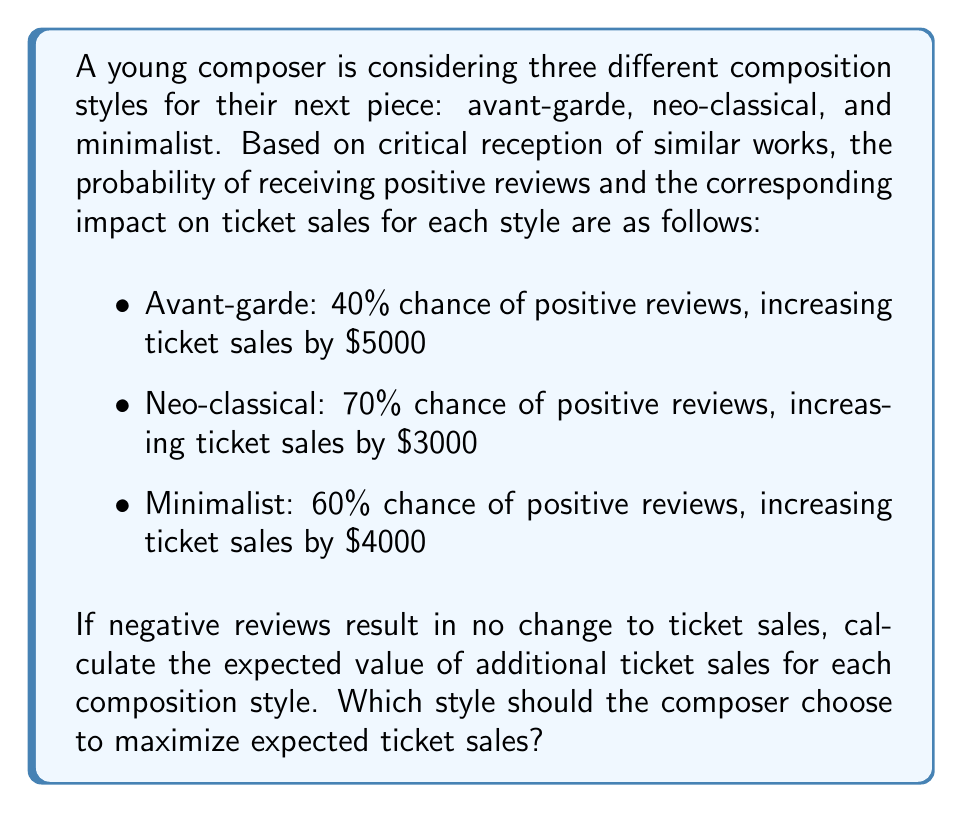Teach me how to tackle this problem. To solve this problem, we need to calculate the expected value for each composition style using the given probabilities and potential outcomes. The expected value is calculated by multiplying each possible outcome by its probability and then summing these products.

1. Avant-garde style:
   Probability of positive reviews: 40% = 0.4
   Probability of negative reviews: 60% = 0.6
   
   Expected Value = (Probability of positive reviews × Increase in ticket sales) + (Probability of negative reviews × No change in ticket sales)
   $$ EV_{avant-garde} = (0.4 \times \$5000) + (0.6 \times \$0) = \$2000 $$

2. Neo-classical style:
   Probability of positive reviews: 70% = 0.7
   Probability of negative reviews: 30% = 0.3
   
   $$ EV_{neo-classical} = (0.7 \times \$3000) + (0.3 \times \$0) = \$2100 $$

3. Minimalist style:
   Probability of positive reviews: 60% = 0.6
   Probability of negative reviews: 40% = 0.4
   
   $$ EV_{minimalist} = (0.6 \times \$4000) + (0.4 \times \$0) = \$2400 $$

Comparing the expected values:
$$ EV_{minimalist} > EV_{neo-classical} > EV_{avant-garde} $$
$$ \$2400 > \$2100 > \$2000 $$

Therefore, the minimalist style has the highest expected value of additional ticket sales.
Answer: The expected values of additional ticket sales for each style are:
Avant-garde: $2000
Neo-classical: $2100
Minimalist: $2400

The composer should choose the minimalist style to maximize expected ticket sales, as it has the highest expected value of $2400. 